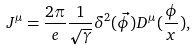Convert formula to latex. <formula><loc_0><loc_0><loc_500><loc_500>J ^ { \mu } = \frac { 2 \pi } { e } \frac { 1 } { \sqrt { \gamma } } \delta ^ { 2 } ( \vec { \phi } ) D ^ { \mu } ( \frac { \phi } { x } ) ,</formula> 